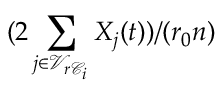Convert formula to latex. <formula><loc_0><loc_0><loc_500><loc_500>( 2 \sum _ { j \in \mathcal { V } _ { r \mathcal { C } _ { i } } } X _ { j } ( t ) ) / ( r _ { 0 } n )</formula> 